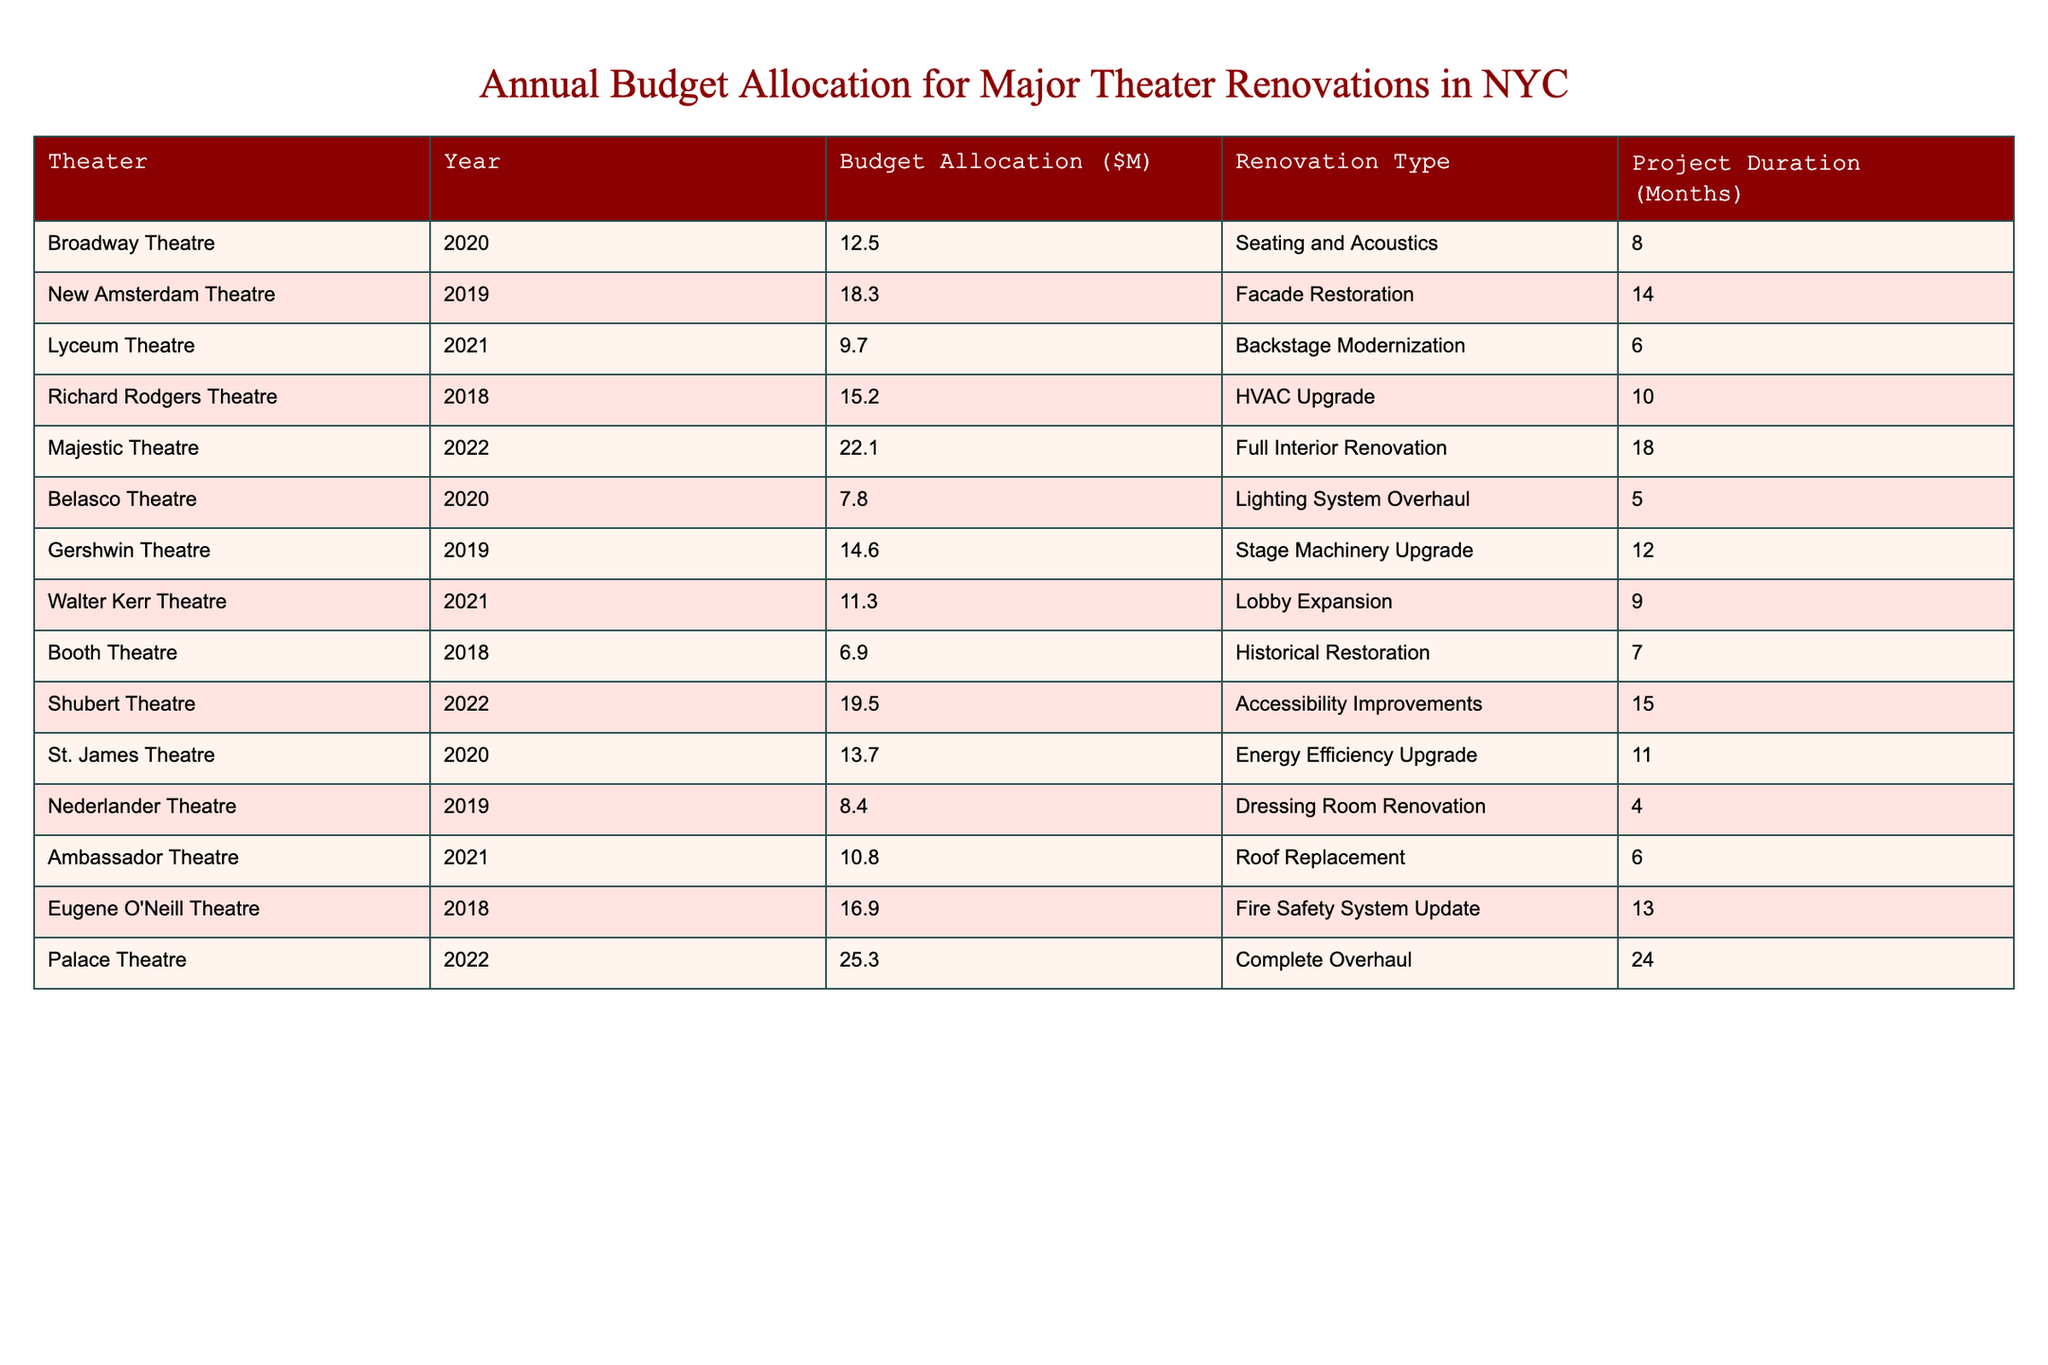What is the budget allocation for the Palace Theatre in 2022? The table shows that the budget allocation for the Palace Theatre in 2022 is 25.3 million dollars.
Answer: 25.3 million Which renovation at the New Amsterdam Theatre had the largest budget allocation? The New Amsterdam Theatre's facade restoration in 2019 had a budget allocation of 18.3 million dollars, which is the largest among its renovations.
Answer: 18.3 million How many months did the Majestic Theatre's full interior renovation take? According to the table, the Majestic Theatre's full interior renovation in 2022 took 18 months.
Answer: 18 months What is the average budget allocation for theater renovations in 2021? For 2021, the budget allocations are 9.7 million (Lyceum), 11.3 million (Walter Kerr), and 10.8 million (Ambassador). The average is (9.7 + 11.3 + 10.8) / 3 = 10.6 million.
Answer: 10.6 million Was the budget allocation for the Belasco Theatre in 2020 less than 10 million? The table indicates that the budget allocation for the Belasco Theatre in 2020 is 7.8 million dollars, which is indeed less than 10 million.
Answer: Yes What was the total budget allocation for theaters renovated in 2019? Adding the budget allocations for theaters renovated in 2019: New Amsterdam (18.3M), Gershwin (14.6M), and Nederlander (8.4M). The total is 18.3 + 14.6 + 8.4 = 41.3 million.
Answer: 41.3 million Which theater had the lowest budget allocation in 2018? The table shows that the Booth Theatre had the lowest budget allocation in 2018, which was 6.9 million dollars.
Answer: Booth Theatre How does the budget allocation for the Richard Rodgers Theatre in 2018 compare to the one for the St. James Theatre in 2020? The budget for the Richard Rodgers Theatre in 2018 was 15.2 million, while the St. James Theatre in 2020 had 13.7 million. Since 15.2 million is greater than 13.7 million, it indicates that the Richard Rodgers had a larger allocation.
Answer: Richard Rodgers Theatre had a larger allocation What is the total project duration for the theaters renovated in 2020? The project durations for theaters renovated in 2020 are 8 months (Broadway), 5 months (Belasco), and 11 months (St. James). Summing these, we find 8 + 5 + 11 = 24 months total.
Answer: 24 months Which type of renovation had the highest budget and what theater did it belong to? The full interior renovation at the Palace Theatre in 2022 had the highest budget allocation of 25.3 million dollars according to the table.
Answer: Full Interior Renovation at Palace Theatre 